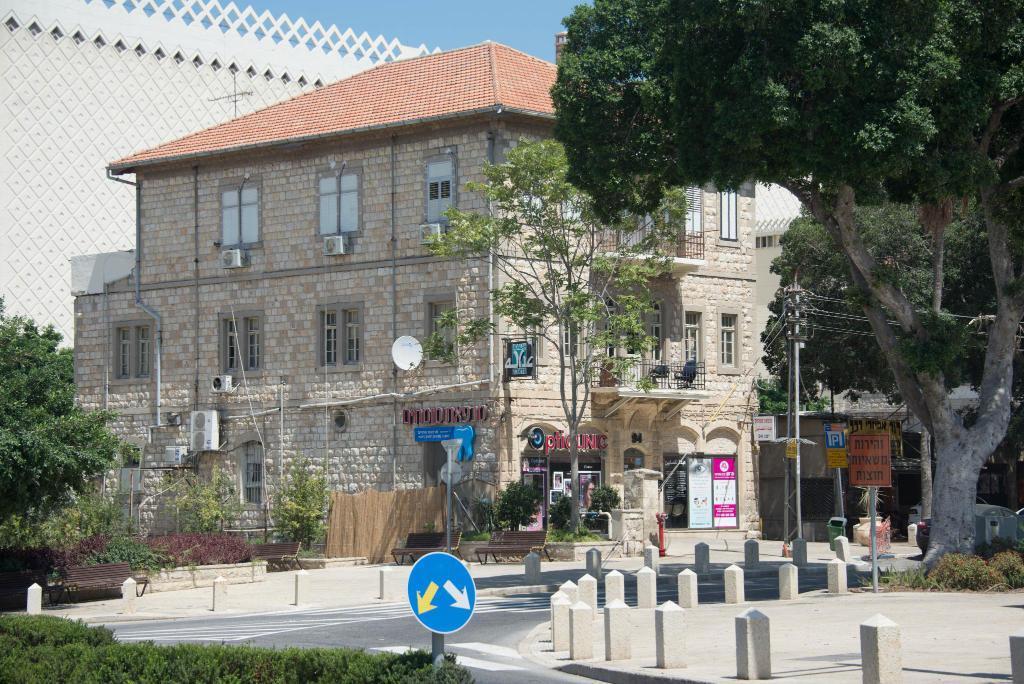In one or two sentences, can you explain what this image depicts? On the right there are trees, plant, board, current pole, cables and other objects. In the foreground there are plants, road and a sign board. In the center of the picture there are plants, tree, air conditioner, building and other objects. On the left there are trees, plant and a wall. 